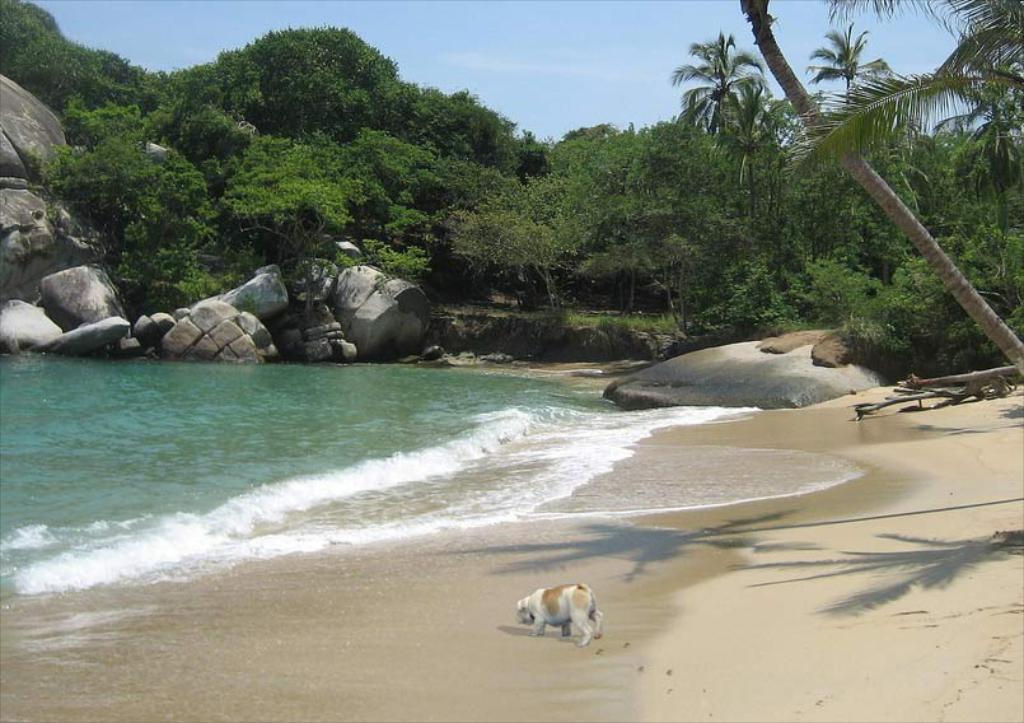What type of animal can be seen in the image? There is a dog in the image. Where is the dog located? The dog is on the seashore. What other natural elements are visible in the image? There are rocks and trees visible in the image. What is visible at the top of the image? The sky is visible at the top of the image. What scale is used to measure the dog's weight in the image? There is no scale present in the image, and the dog's weight cannot be measured from the image. What type of work is the dog performing in the image? The dog is not performing any work in the image; it is simply on the seashore. 